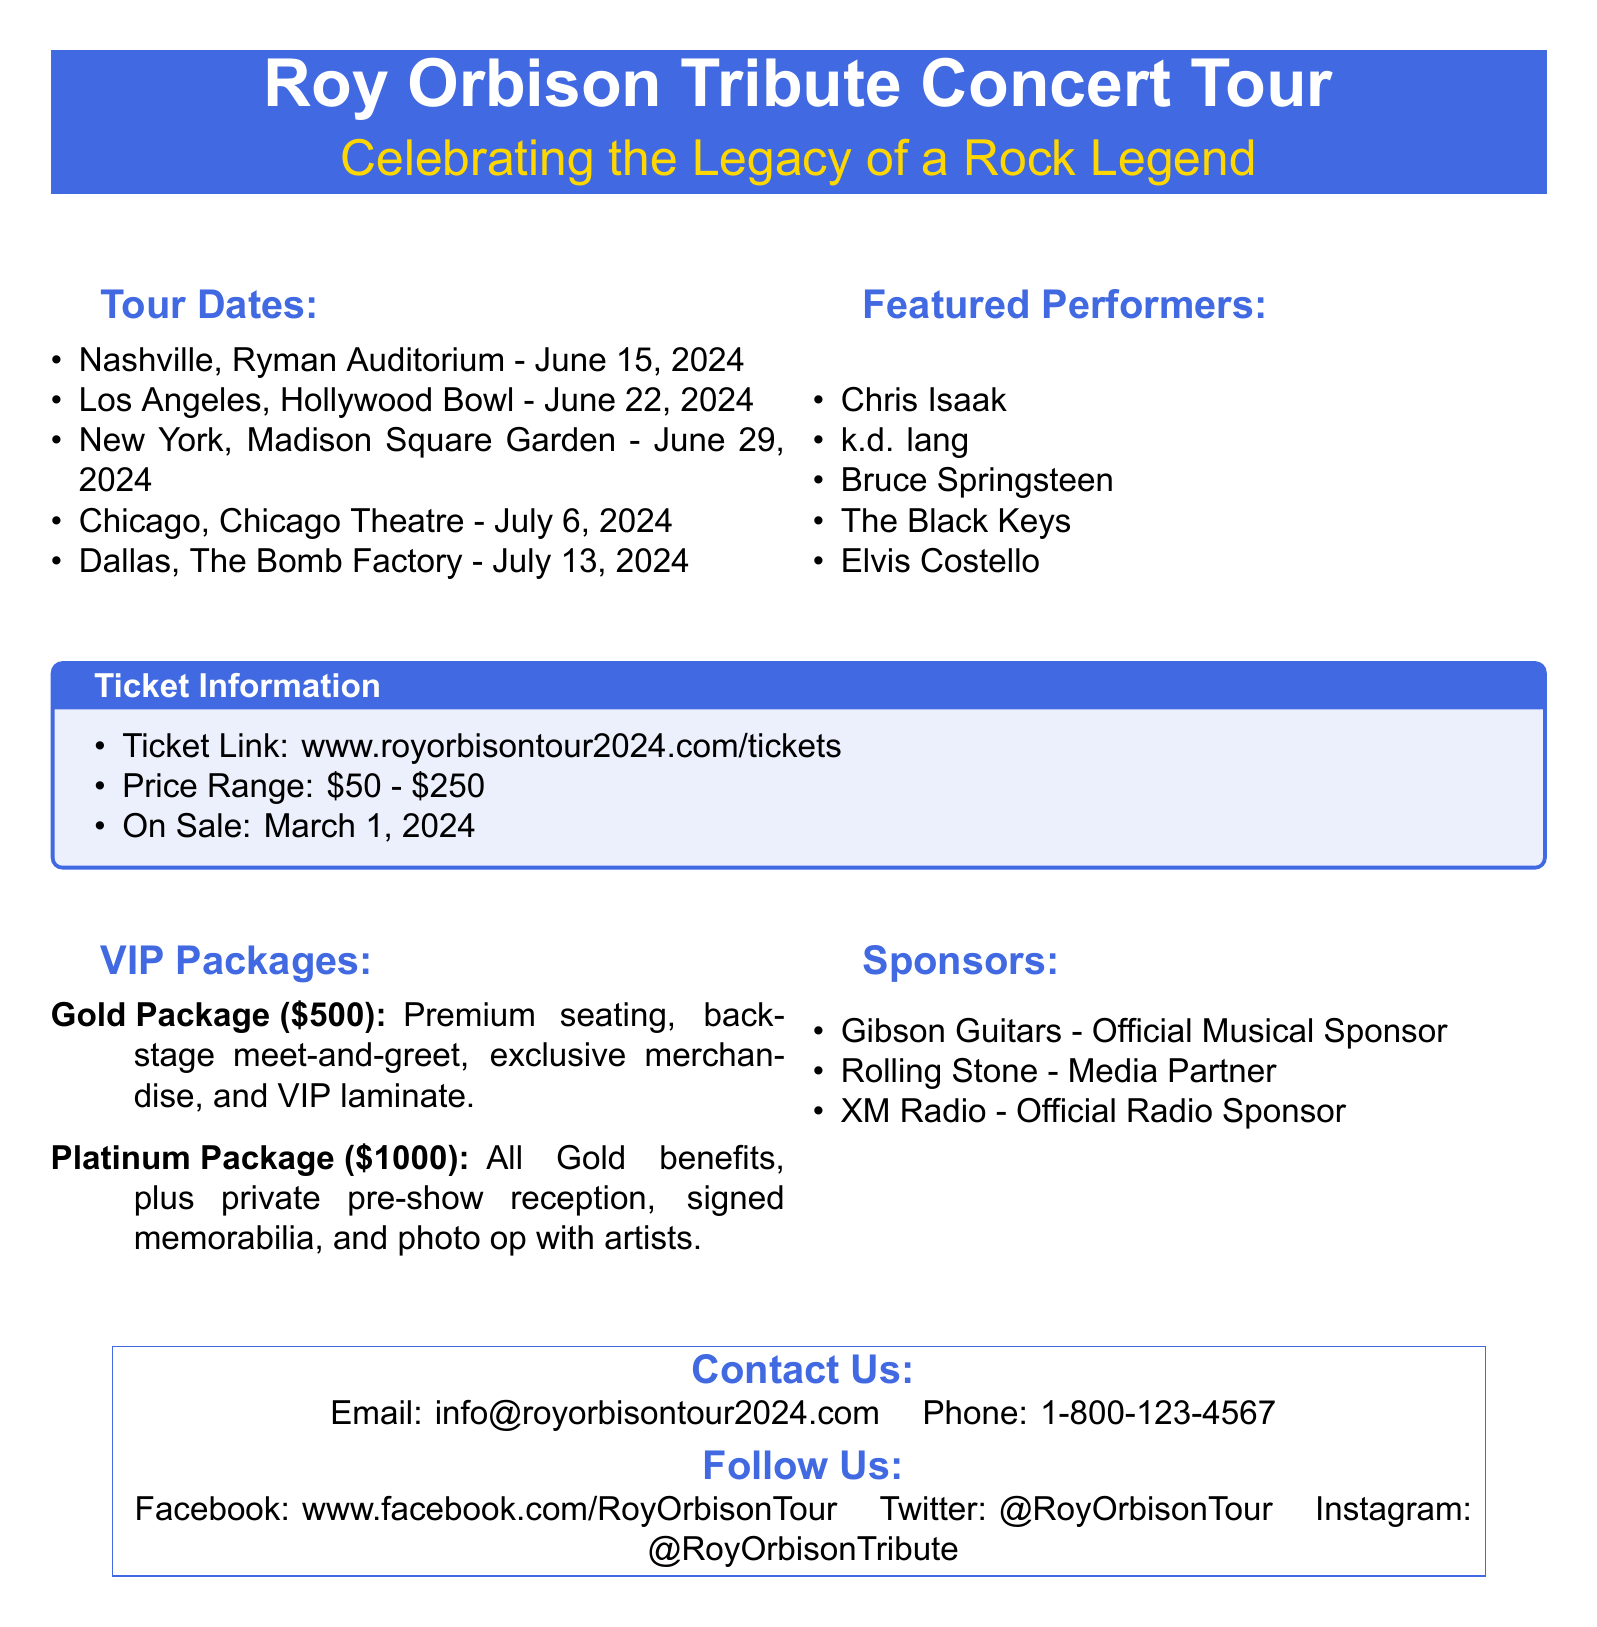what is the name of the concert tour? The advertisement mentions the title of the concert tour as "Roy Orbison Tribute Concert Tour."
Answer: Roy Orbison Tribute Concert Tour when does the concert take place in Nashville? The document lists the date for the Nashville concert as June 15, 2024.
Answer: June 15, 2024 who are three featured performers at the concert? The document provides a list of featured performers including Chris Isaak, k.d. lang, and Bruce Springsteen.
Answer: Chris Isaak, k.d. lang, Bruce Springsteen what is the price range for tickets? The document states that the ticket price range is between $50 and $250.
Answer: $50 - $250 what is included in the Gold VIP Package? The advertisement specifies that the Gold Package includes premium seating, backstage meet-and-greet, exclusive merchandise, and VIP laminate.
Answer: Premium seating, backstage meet-and-greet, exclusive merchandise, and VIP laminate when do tickets go on sale? The document indicates that tickets will go on sale on March 1, 2024.
Answer: March 1, 2024 how much is the Platinum VIP Package? According to the document, the cost for the Platinum Package is $1000.
Answer: $1000 what is the email contact for the tour? The advertisement provides an email contact as info@royorbisontour2024.com.
Answer: info@royorbisontour2024.com 